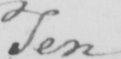Transcribe the text shown in this historical manuscript line. Ten 